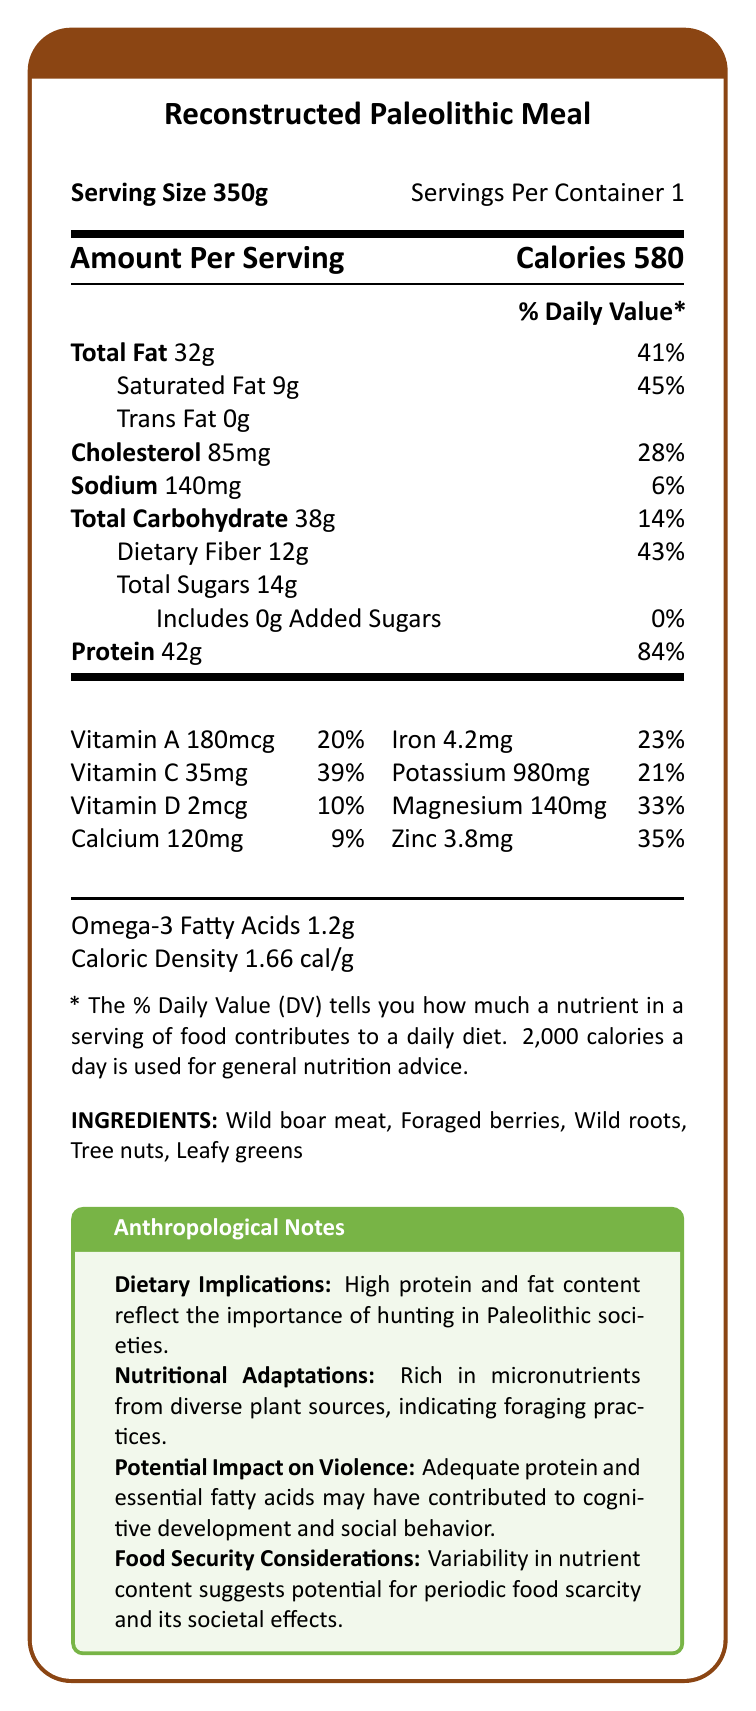what is the serving size for the Reconstructed Paleolithic Meal? The serving size is shown at the top of the document in the section labeled "Serving Size."
Answer: 350g how many calories are in a serving of the Reconstructed Paleolithic Meal? The calorie content is displayed prominently under the "Amount Per Serving" section.
Answer: 580 calories what percentage of the daily value of dietary fiber does this meal provide? The daily value percentage for dietary fiber is listed under the "Total Carbohydrate" section.
Answer: 43% how much protein does one serving contain? The protein content per serving is shown in grams and its daily value percentage under the "Protein" section.
Answer: 42g what are the main ingredients in this reconstructed Paleolithic meal? The ingredients are listed at the bottom of the document under "INGREDIENTS."
Answer: Wild boar meat, Foraged berries, Wild roots, Tree nuts, Leafy greens which nutrient has the highest percentage of the daily value in this meal? A. Protein B. Saturated Fat C. Magnesium The protein has a daily value percentage of 84%, which is higher than the others listed.
Answer: A. Protein how many grams of total fat are there in one serving? The total fat amount is detailed in the "Total Fat" section.
Answer: 32g what is the caloric density of this meal? The caloric density is specified at the end of the nutrition details under "Caloric Density."
Answer: 1.66 cal/g is there any trans fat in this meal? The document lists Trans Fat as 0g, indicating there is none.
Answer: No which of the following best explains the overall dietary implications of this meal? A. It is rich in carbohydrates B. It focuses on high protein and fat from hunting C. It lacks essential nutrients The "Dietary Implications" in the "Anthropological Notes" mention high protein and fat content reflecting the importance of hunting in Paleolithic societies.
Answer: B. It focuses on high protein and fat from hunting based on the information, what might be the connection between the nutrient profile of the meal and social behavior in Paleolithic societies? The "Potential Impact on Violence" section mentions this connection, suggesting that the nutrients improved cognitive development and social behavior.
Answer: Adequate protein and essential fatty acids may have contributed to cognitive development and social behavior. how much magnesium is present in this meal, and what percentage of the daily value does it represent? The magnesium content and its daily value are listed in the "Vitamin and Mineral" section.
Answer: 140mg, 33% summarize the main points of the document. The summary explains the main contents, including the nutritional composition and anthropological implications of the meal.
Answer: The document provides the nutrition facts for a Reconstructed Paleolithic Meal, detailing its caloric content, macro and micronutrients, and ingredients. The meal is high in proteins and fats, reflecting hunter-gatherer diets, and is rich in micronutrients from diverse plant sources. The anthropological notes link the nutritional profile to societal behaviors, such as cognitive development and social stability. what was the average lifespan of individuals in Paleolithic societies? The document does not provide any information on the average lifespan of individuals in Paleolithic societies.
Answer: Cannot be determined 